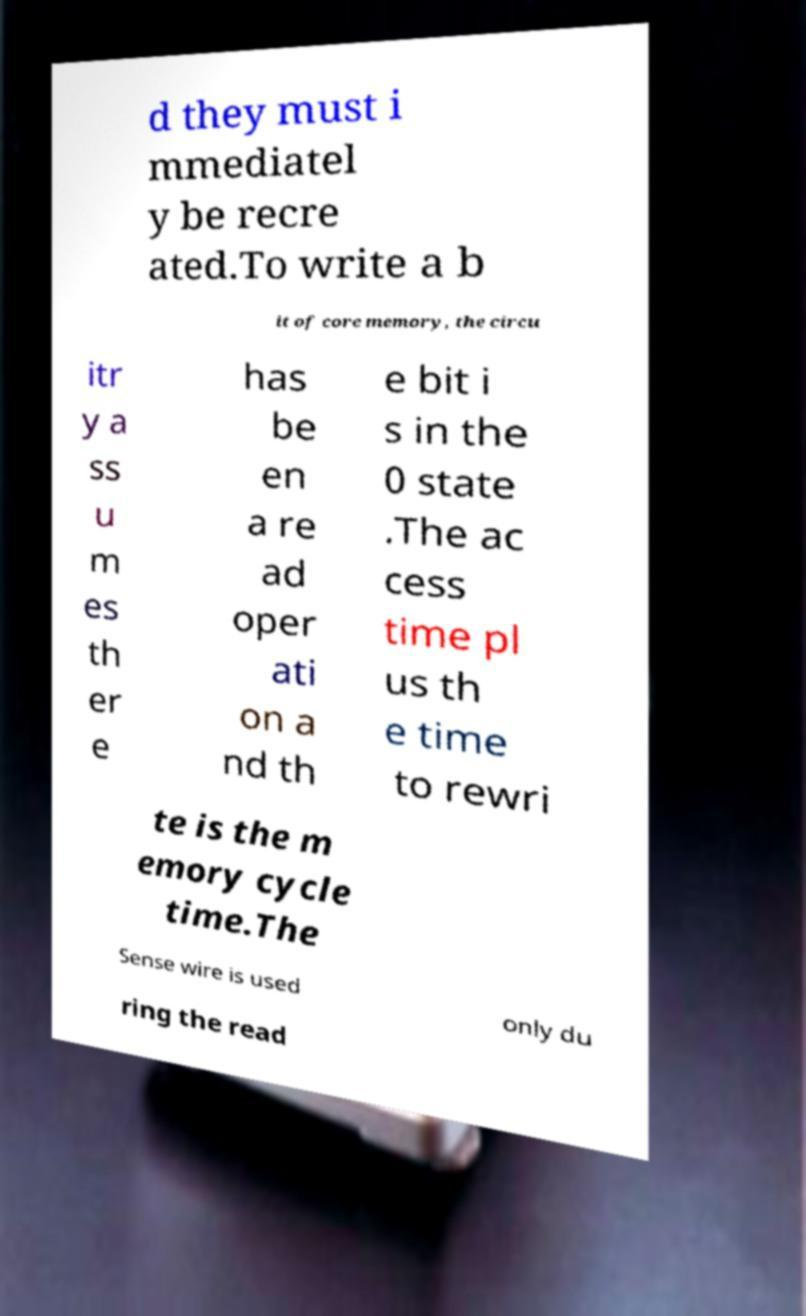Can you read and provide the text displayed in the image?This photo seems to have some interesting text. Can you extract and type it out for me? d they must i mmediatel y be recre ated.To write a b it of core memory, the circu itr y a ss u m es th er e has be en a re ad oper ati on a nd th e bit i s in the 0 state .The ac cess time pl us th e time to rewri te is the m emory cycle time.The Sense wire is used only du ring the read 